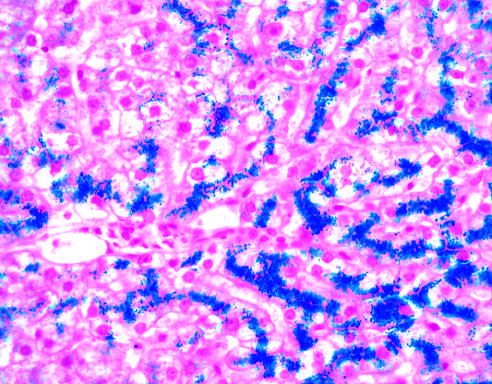what appears blue in this prussian blue-stained section?
Answer the question using a single word or phrase. Hepatocellular iron 